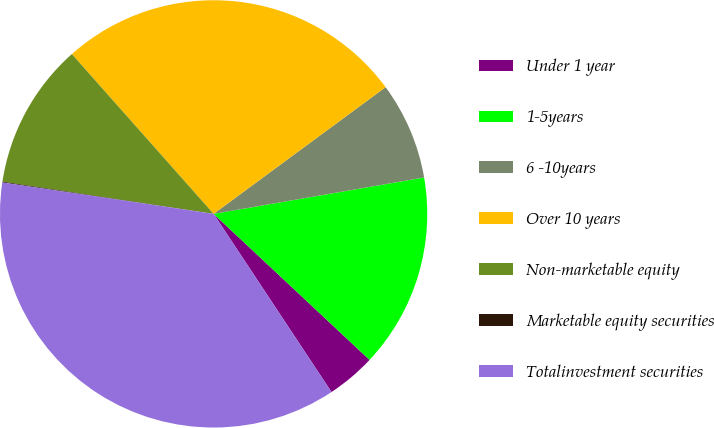Convert chart. <chart><loc_0><loc_0><loc_500><loc_500><pie_chart><fcel>Under 1 year<fcel>1-5years<fcel>6 -10years<fcel>Over 10 years<fcel>Non-marketable equity<fcel>Marketable equity securities<fcel>Totalinvestment securities<nl><fcel>3.72%<fcel>14.7%<fcel>7.38%<fcel>26.44%<fcel>11.04%<fcel>0.06%<fcel>36.65%<nl></chart> 